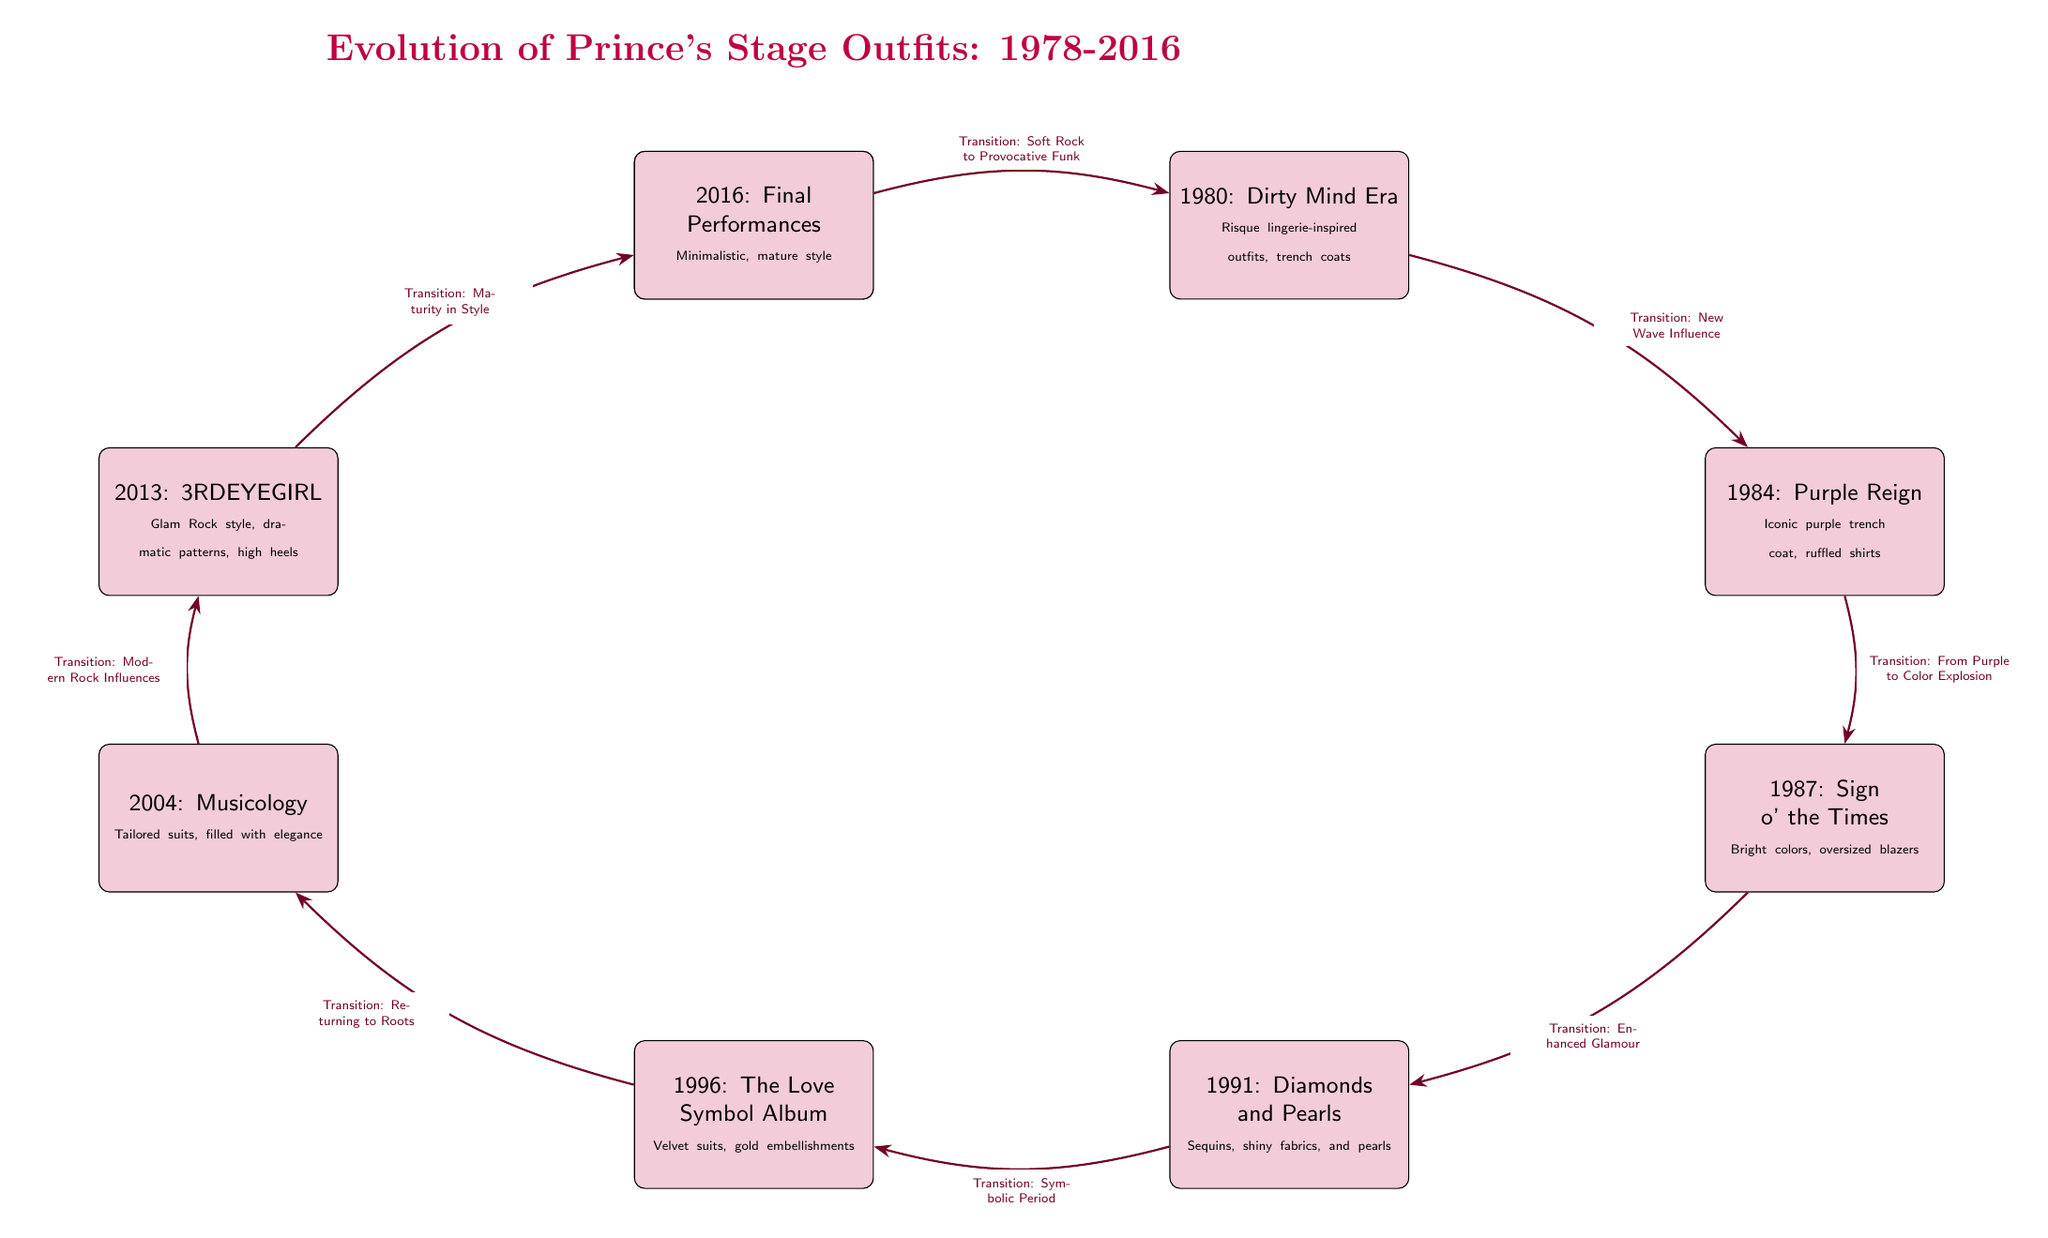What year represents Prince's debut look? The diagram identifies 1978 as the year of Prince's debut look. This is the first node positioned at the top left and labeled accordingly.
Answer: 1978 What kind of outfits characterize the "Dirty Mind" era? The node for the year 1980 describes "Dirty Mind" era outfits as "risque lingerie-inspired outfits, trench coats". This information is directly stated in the corresponding node.
Answer: Risque lingerie-inspired outfits, trench coats How many major outfit transitions are depicted in the diagram? Counting the edges connecting the nodes, there are a total of 7 transitions shown in the diagram from 1978 to 2016, indicating the evolution of style.
Answer: 7 What significant change is noted in Prince's style from 1991 to 1996? The transition from 1991 (Diamonds and Pearls) to 1996 (The Love Symbol Album) is characterized as the "Symbolic Period," indicating a notable transition in style emphasis and aesthetics.
Answer: Symbolic Period Which year marks the transition to modern rock influences in Prince's outfits? Upon examining the nodes, the transition to modern rock influences is noted in 2013, as indicated between the nodes for 2004 and 2013.
Answer: 2013 What was the style description for Prince's final performances in 2016? The final node for the year 2016 states the style as "minimalistic, mature style," clearly summarizing the shift in fashion approach during this period.
Answer: Minimalistic, mature style In what year did Prince adopt "Glam Rock style"? The node for the year 2013 explicitly states that during this time, Prince adopted "Glam Rock style, dramatic patterns, high heels," making it clear which year features this style.
Answer: 2013 What can be inferred about the trend of Prince's stage outfits based on the nodes? By examining the nodes chronologically, one can infer a progression from flamboyant and colorful styles to more minimalistic and mature choices, indicating a potential evolution in his artistic expression and personal growth over time.
Answer: Progression from flamboyant to minimalistic styles 